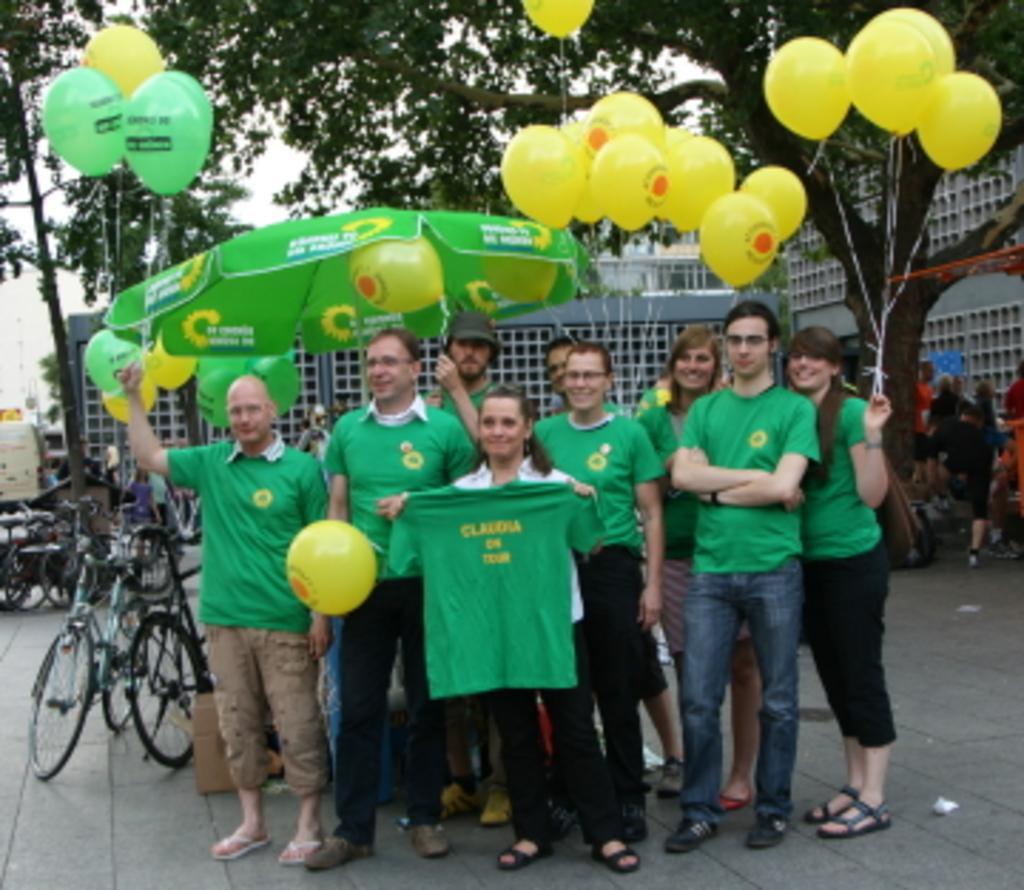How would you summarize this image in a sentence or two? In this image we can see few people standing. Some are holding balloons. And one lady is holding a t shirt. In the back there is an umbrella. Also there are cycles. In the background there are trees, buildings and sky. And one person is wearing a cap. 